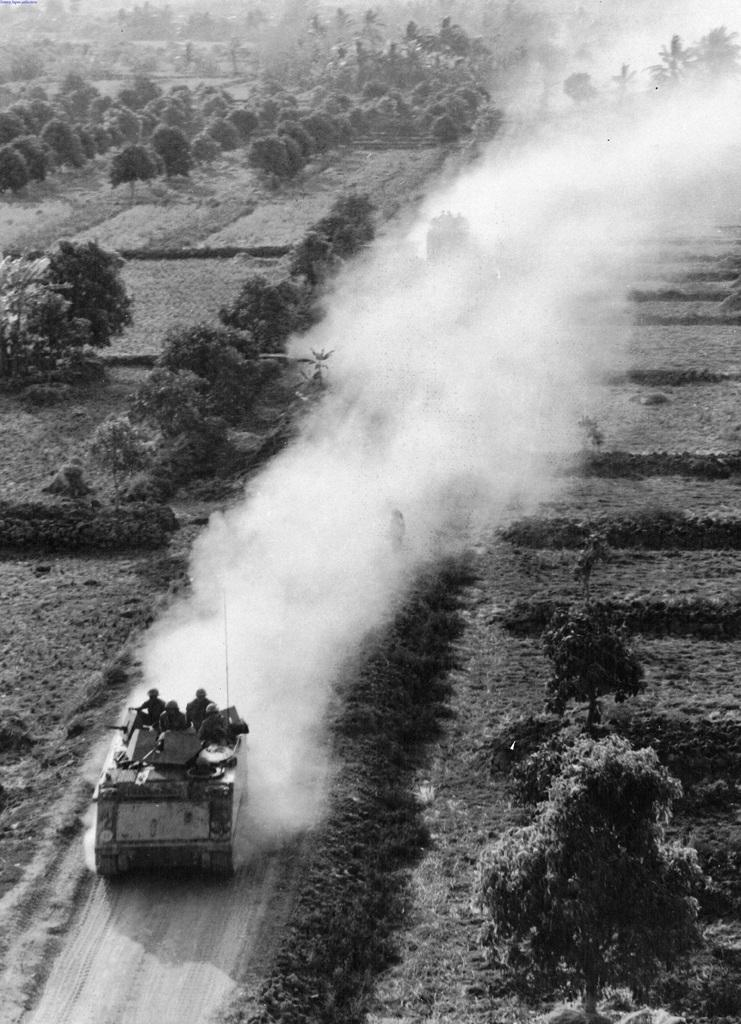What type of vehicles can be seen in the image? There are military vehicles in the image. What other elements are present in the image besides the vehicles? There are plants, trees, and grass on the ground in the image. How many cups can be seen on the bookshelf in the image? There is no bookshelf or cup present in the image. 